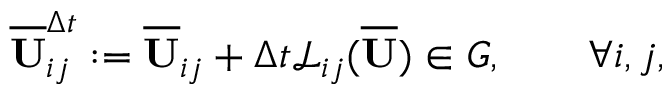<formula> <loc_0><loc_0><loc_500><loc_500>\overline { U } _ { i j } ^ { \Delta t } \colon = \overline { U } _ { i j } + \Delta t \mathcal { L } _ { i j } ( \overline { U } ) \in G , \quad \forall i , j ,</formula> 